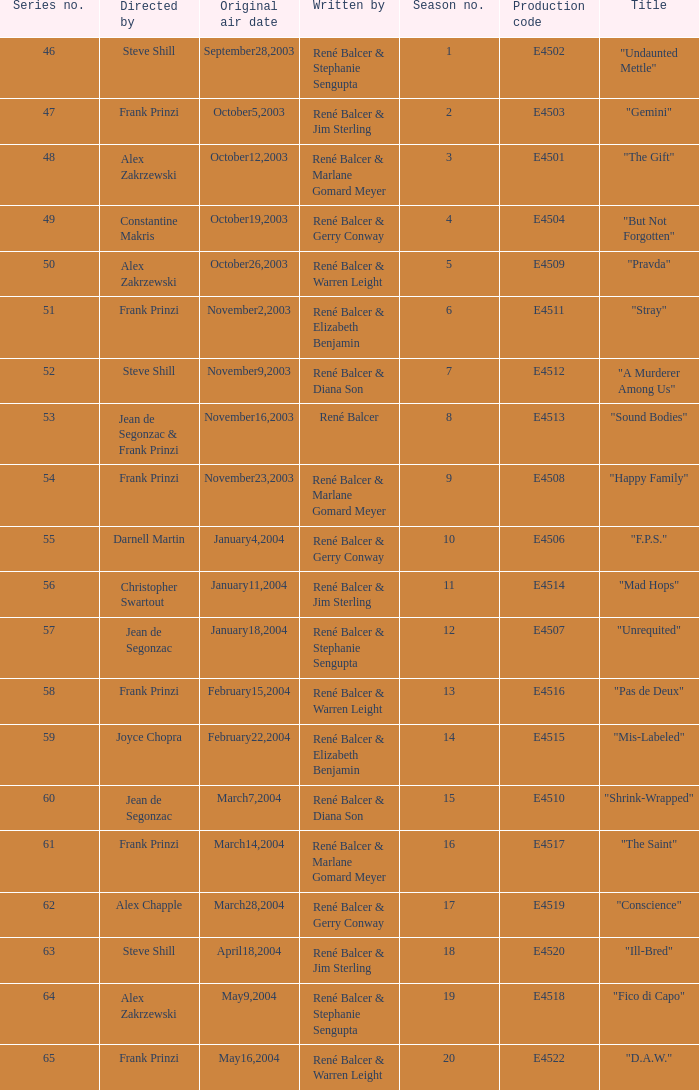Who wrote the episode with e4515 as the production code? René Balcer & Elizabeth Benjamin. 